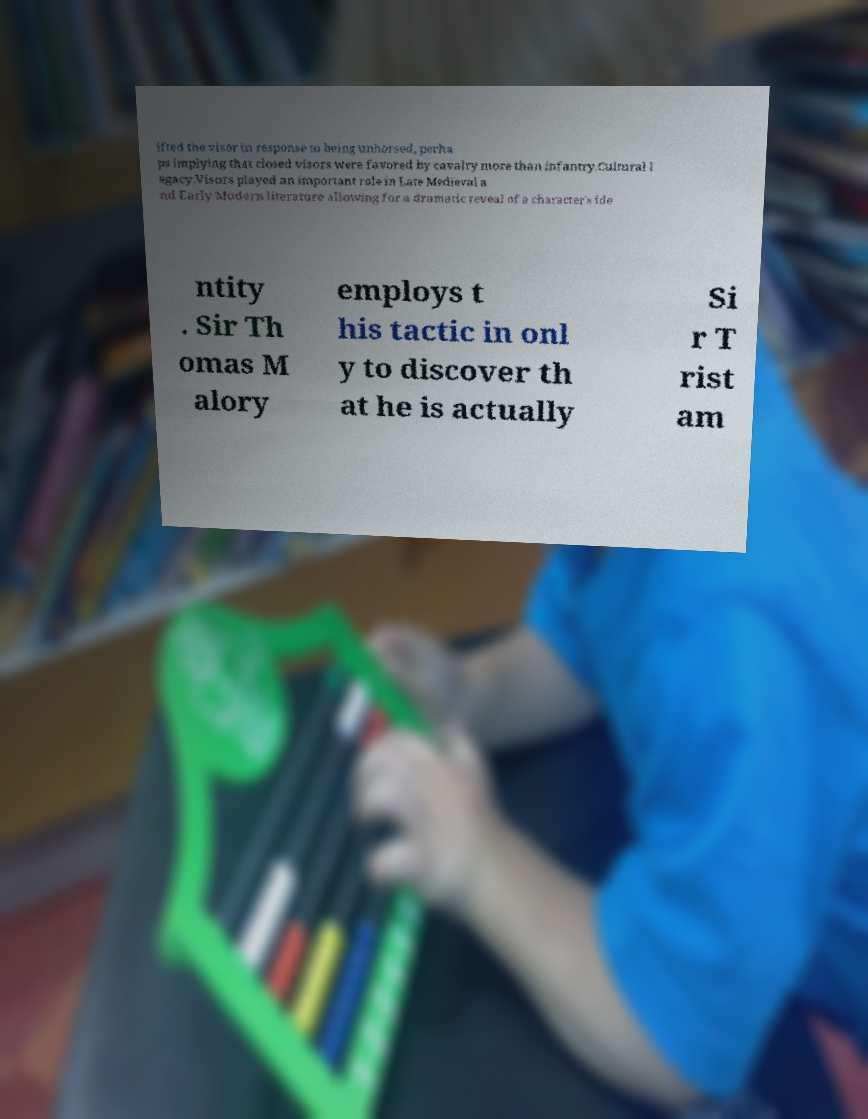I need the written content from this picture converted into text. Can you do that? ifted the visor in response to being unhorsed, perha ps implying that closed visors were favored by cavalry more than infantry.Cultural l egacy.Visors played an important role in Late Medieval a nd Early Modern literature allowing for a dramatic reveal of a character's ide ntity . Sir Th omas M alory employs t his tactic in onl y to discover th at he is actually Si r T rist am 